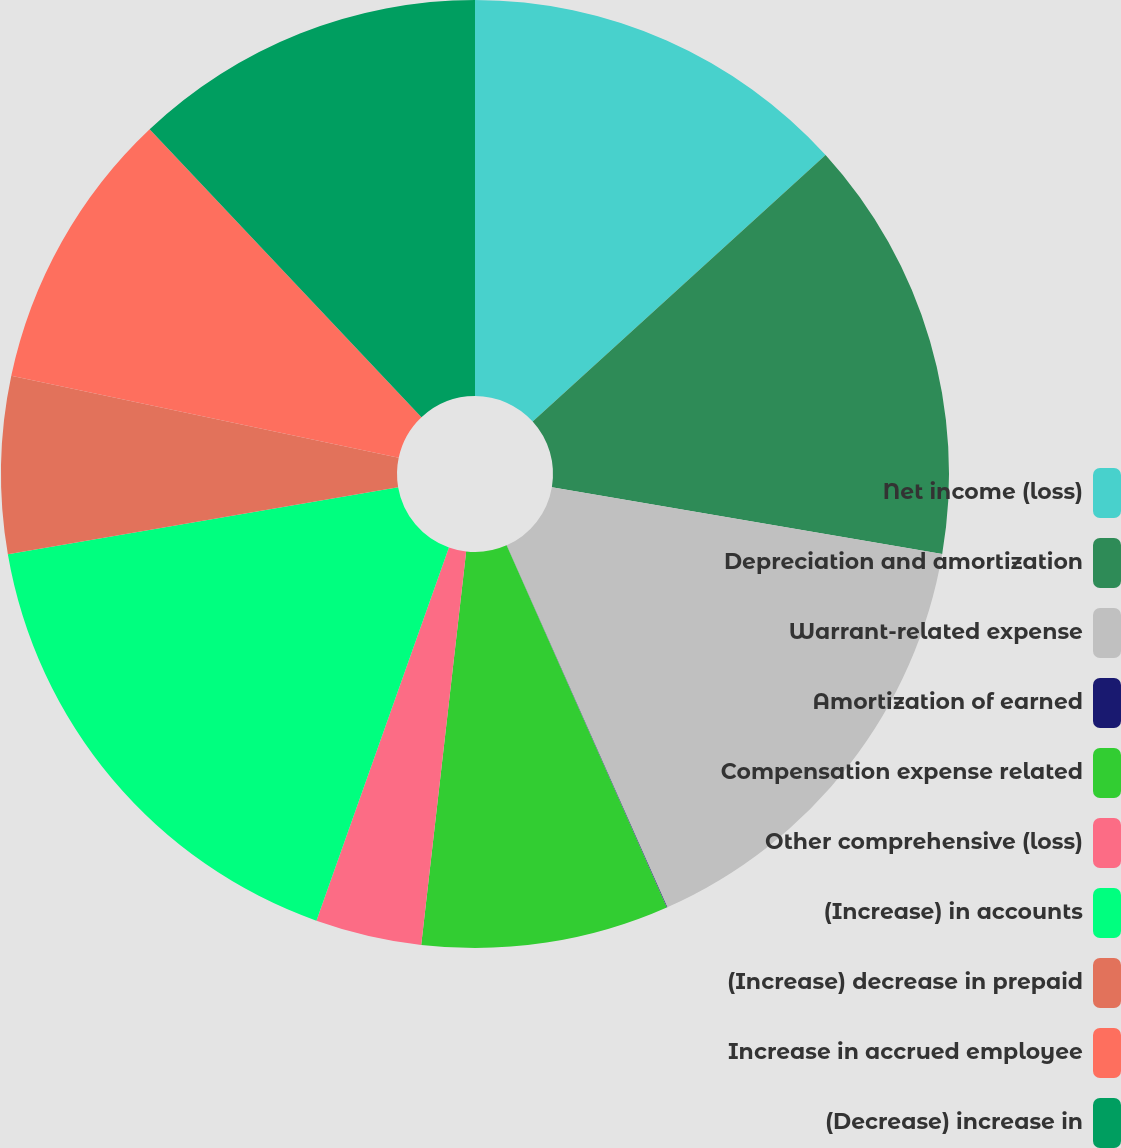Convert chart to OTSL. <chart><loc_0><loc_0><loc_500><loc_500><pie_chart><fcel>Net income (loss)<fcel>Depreciation and amortization<fcel>Warrant-related expense<fcel>Amortization of earned<fcel>Compensation expense related<fcel>Other comprehensive (loss)<fcel>(Increase) in accounts<fcel>(Increase) decrease in prepaid<fcel>Increase in accrued employee<fcel>(Decrease) increase in<nl><fcel>13.25%<fcel>14.45%<fcel>15.65%<fcel>0.02%<fcel>8.44%<fcel>3.62%<fcel>16.86%<fcel>6.03%<fcel>9.64%<fcel>12.04%<nl></chart> 